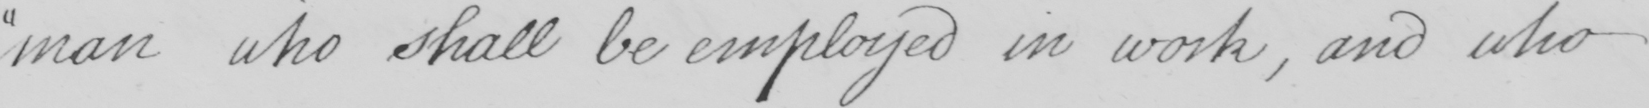What is written in this line of handwriting? man who shall be employed in work , and who 